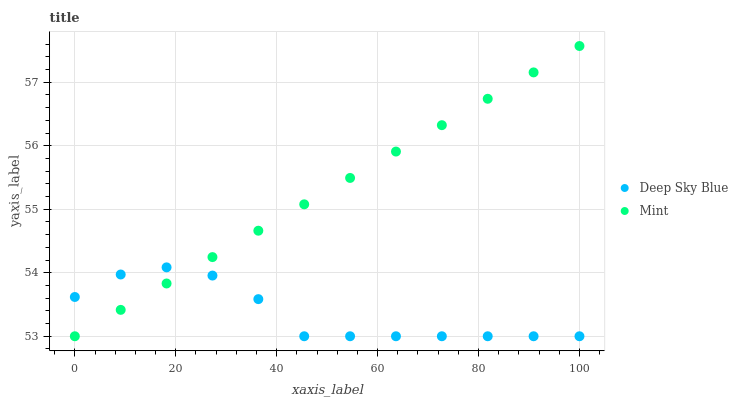Does Deep Sky Blue have the minimum area under the curve?
Answer yes or no. Yes. Does Mint have the maximum area under the curve?
Answer yes or no. Yes. Does Deep Sky Blue have the maximum area under the curve?
Answer yes or no. No. Is Mint the smoothest?
Answer yes or no. Yes. Is Deep Sky Blue the roughest?
Answer yes or no. Yes. Is Deep Sky Blue the smoothest?
Answer yes or no. No. Does Mint have the lowest value?
Answer yes or no. Yes. Does Mint have the highest value?
Answer yes or no. Yes. Does Deep Sky Blue have the highest value?
Answer yes or no. No. Does Deep Sky Blue intersect Mint?
Answer yes or no. Yes. Is Deep Sky Blue less than Mint?
Answer yes or no. No. Is Deep Sky Blue greater than Mint?
Answer yes or no. No. 